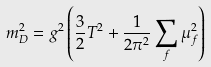Convert formula to latex. <formula><loc_0><loc_0><loc_500><loc_500>m _ { D } ^ { 2 } = g ^ { 2 } \left ( \frac { 3 } { 2 } T ^ { 2 } + \frac { 1 } { 2 \pi ^ { 2 } } \sum _ { f } { \mu _ { f } ^ { 2 } } \right )</formula> 